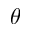<formula> <loc_0><loc_0><loc_500><loc_500>\theta</formula> 